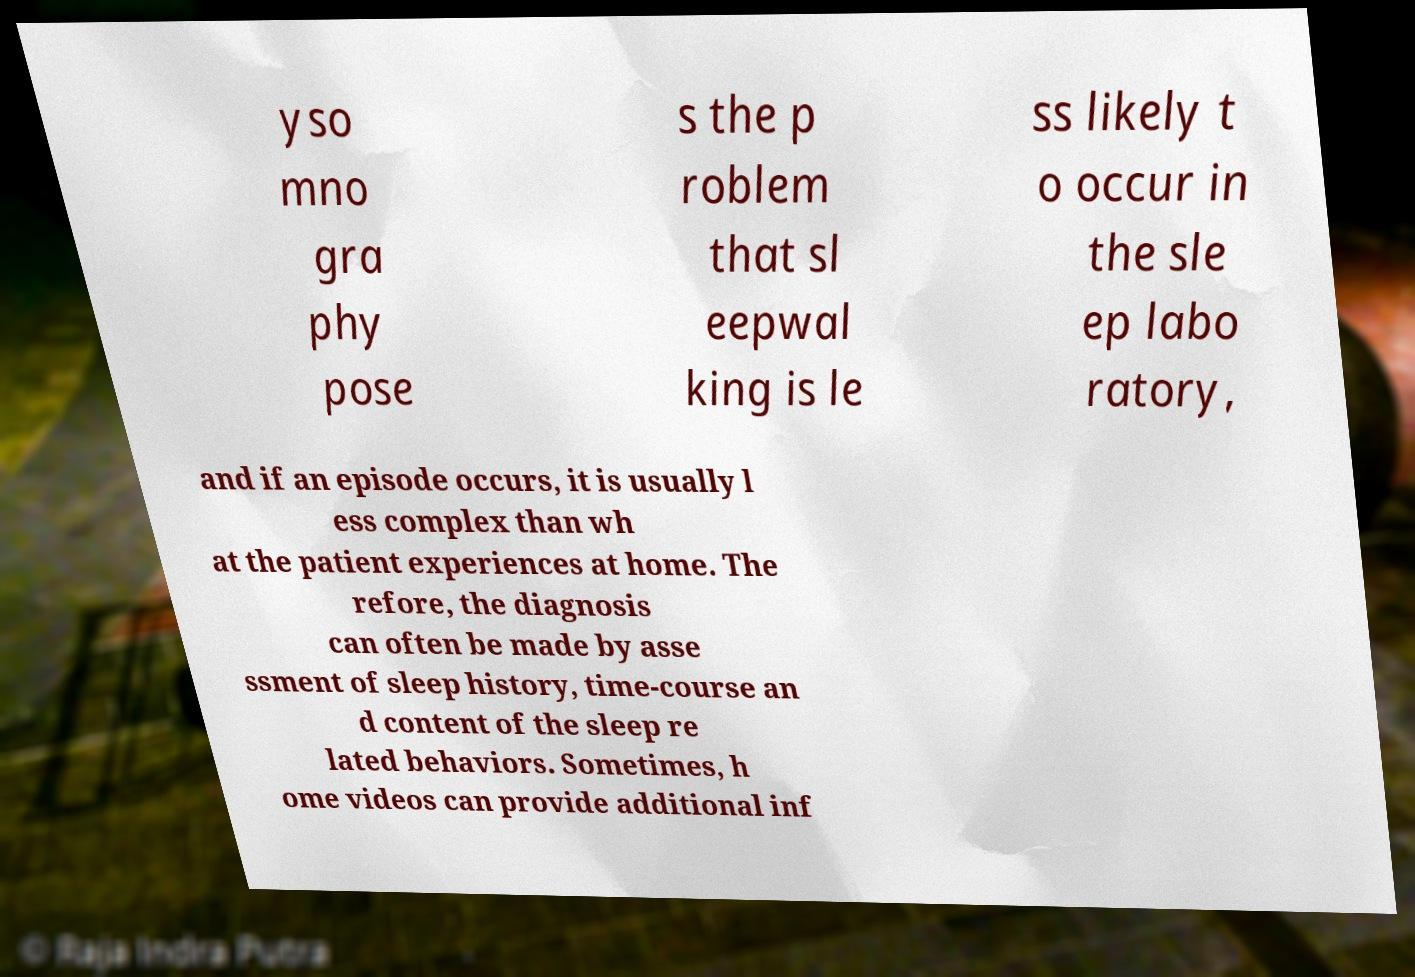Please identify and transcribe the text found in this image. yso mno gra phy pose s the p roblem that sl eepwal king is le ss likely t o occur in the sle ep labo ratory, and if an episode occurs, it is usually l ess complex than wh at the patient experiences at home. The refore, the diagnosis can often be made by asse ssment of sleep history, time-course an d content of the sleep re lated behaviors. Sometimes, h ome videos can provide additional inf 